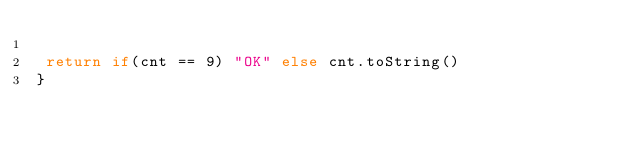Convert code to text. <code><loc_0><loc_0><loc_500><loc_500><_Kotlin_>
 return if(cnt == 9) "OK" else cnt.toString()
}
</code> 